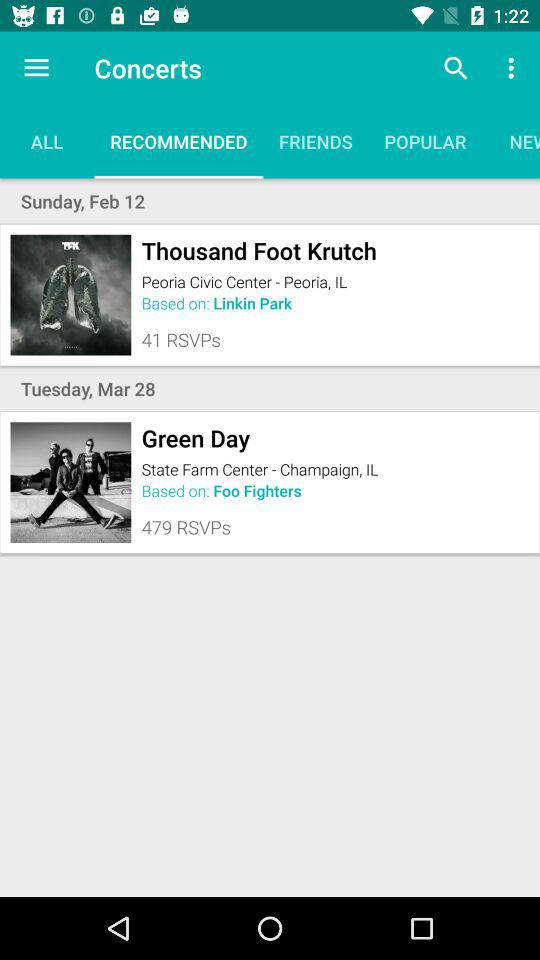What is the date of Green Day? The date is Tuesday, March 28. 